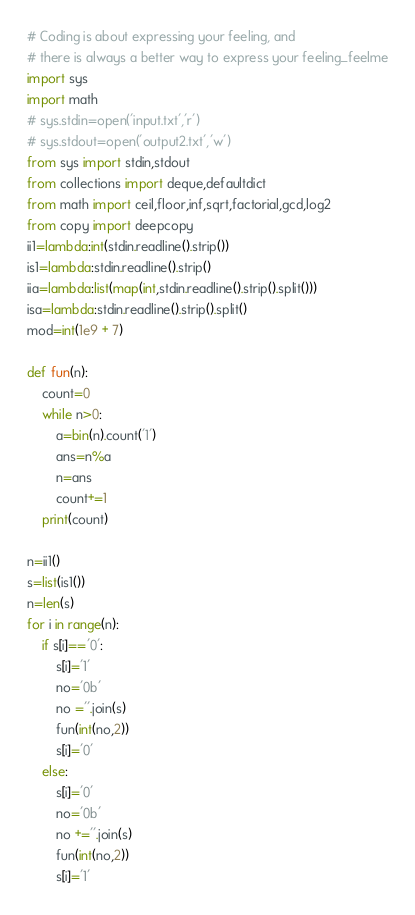Convert code to text. <code><loc_0><loc_0><loc_500><loc_500><_Python_># Coding is about expressing your feeling, and
# there is always a better way to express your feeling_feelme
import sys
import math
# sys.stdin=open('input.txt','r')
# sys.stdout=open('output2.txt','w')
from sys import stdin,stdout
from collections import deque,defaultdict
from math import ceil,floor,inf,sqrt,factorial,gcd,log2
from copy import deepcopy
ii1=lambda:int(stdin.readline().strip())
is1=lambda:stdin.readline().strip()
iia=lambda:list(map(int,stdin.readline().strip().split()))
isa=lambda:stdin.readline().strip().split()
mod=int(1e9 + 7)

def fun(n):
    count=0
    while n>0:
        a=bin(n).count('1')
        ans=n%a
        n=ans
        count+=1
    print(count)

n=ii1()
s=list(is1())
n=len(s)
for i in range(n):
    if s[i]=='0':
        s[i]='1'
        no='0b'
        no =''.join(s)
        fun(int(no,2))
        s[i]='0'
    else:
        s[i]='0'
        no='0b'
        no +=''.join(s)
        fun(int(no,2))
        s[i]='1'
</code> 